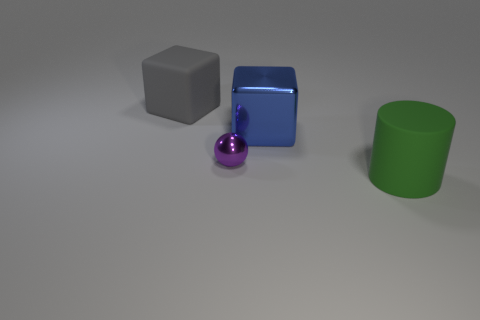Add 2 big gray rubber objects. How many objects exist? 6 Subtract all cylinders. How many objects are left? 3 Add 3 small matte cylinders. How many small matte cylinders exist? 3 Subtract 1 gray blocks. How many objects are left? 3 Subtract all big brown metal blocks. Subtract all small metal balls. How many objects are left? 3 Add 1 small purple metal spheres. How many small purple metal spheres are left? 2 